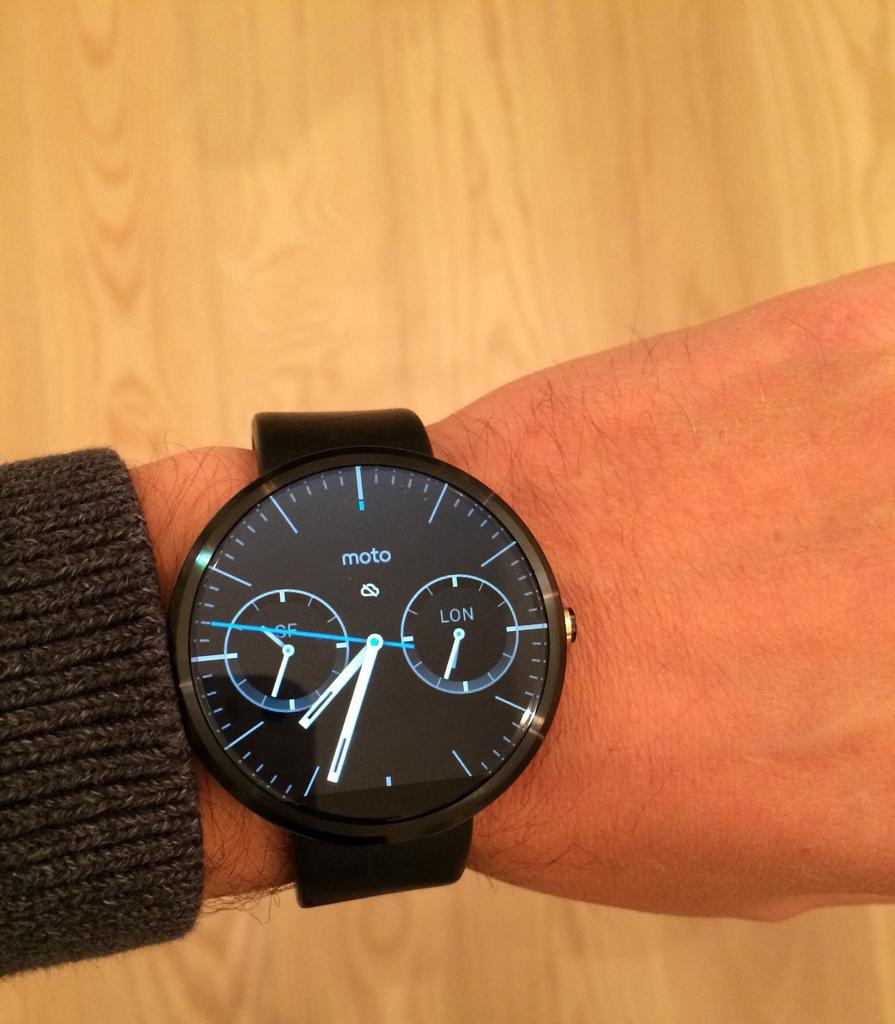Please provide a concise description of this image. In the center of the image there is a person's hand wearing a watch. At the bottom of the image there is a wooden surface. 